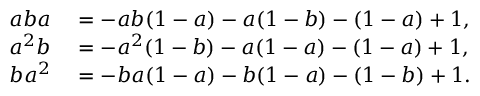Convert formula to latex. <formula><loc_0><loc_0><loc_500><loc_500>\begin{array} { r l } { a b a } & = - a b ( 1 - a ) - a ( 1 - b ) - ( 1 - a ) + 1 , } \\ { a ^ { 2 } b } & = - a ^ { 2 } ( 1 - b ) - a ( 1 - a ) - ( 1 - a ) + 1 , } \\ { b a ^ { 2 } } & = - b a ( 1 - a ) - b ( 1 - a ) - ( 1 - b ) + 1 . } \end{array}</formula> 